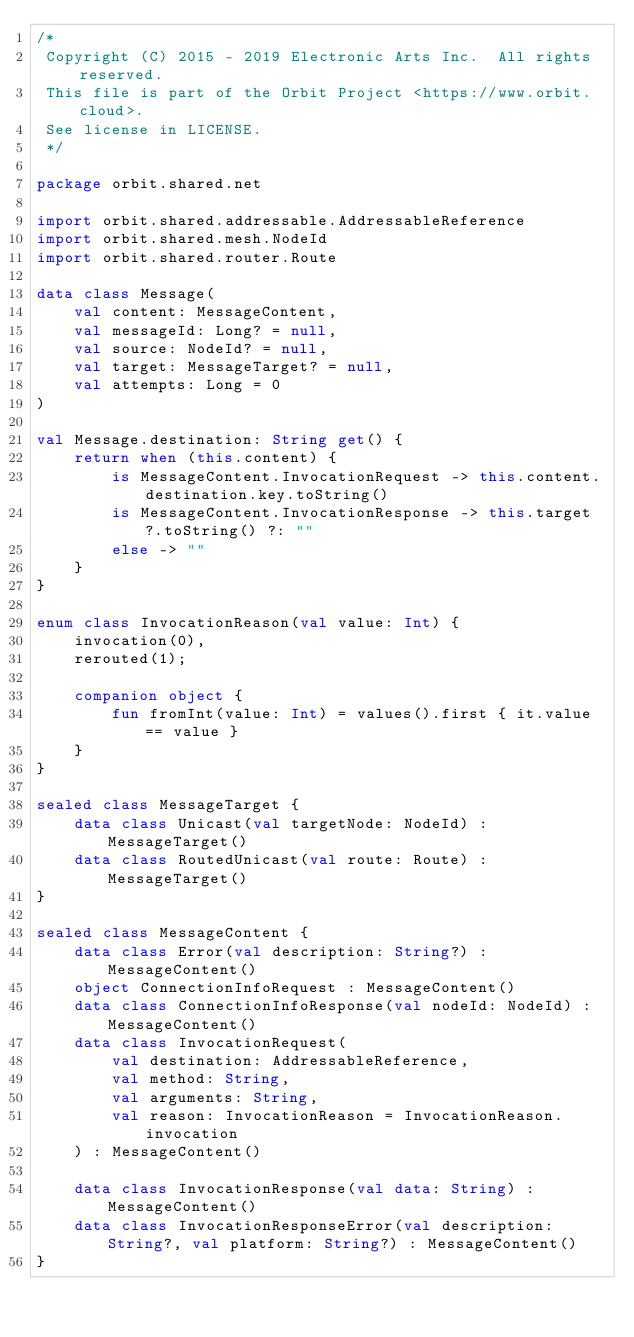Convert code to text. <code><loc_0><loc_0><loc_500><loc_500><_Kotlin_>/*
 Copyright (C) 2015 - 2019 Electronic Arts Inc.  All rights reserved.
 This file is part of the Orbit Project <https://www.orbit.cloud>.
 See license in LICENSE.
 */

package orbit.shared.net

import orbit.shared.addressable.AddressableReference
import orbit.shared.mesh.NodeId
import orbit.shared.router.Route

data class Message(
    val content: MessageContent,
    val messageId: Long? = null,
    val source: NodeId? = null,
    val target: MessageTarget? = null,
    val attempts: Long = 0
)

val Message.destination: String get() {
    return when (this.content) {
        is MessageContent.InvocationRequest -> this.content.destination.key.toString()
        is MessageContent.InvocationResponse -> this.target?.toString() ?: ""
        else -> ""
    }
}

enum class InvocationReason(val value: Int) {
    invocation(0),
    rerouted(1);

    companion object {
        fun fromInt(value: Int) = values().first { it.value == value }
    }
}

sealed class MessageTarget {
    data class Unicast(val targetNode: NodeId) : MessageTarget()
    data class RoutedUnicast(val route: Route) : MessageTarget()
}

sealed class MessageContent {
    data class Error(val description: String?) : MessageContent()
    object ConnectionInfoRequest : MessageContent()
    data class ConnectionInfoResponse(val nodeId: NodeId) : MessageContent()
    data class InvocationRequest(
        val destination: AddressableReference,
        val method: String,
        val arguments: String,
        val reason: InvocationReason = InvocationReason.invocation
    ) : MessageContent()

    data class InvocationResponse(val data: String) : MessageContent()
    data class InvocationResponseError(val description: String?, val platform: String?) : MessageContent()
}</code> 